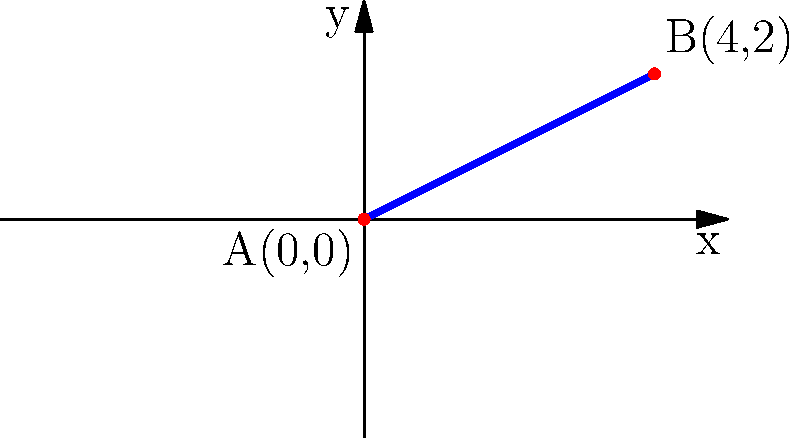During a breakaway, a player skates from point A(0,0) to point B(4,2) on the ice rink. Determine the slope of the line representing the player's path. How does this relate to the player's angle of approach towards the goal? To find the slope of the line representing the player's path, we'll follow these steps:

1) The slope formula is:
   $$ m = \frac{y_2 - y_1}{x_2 - x_1} $$
   where $(x_1, y_1)$ is the starting point and $(x_2, y_2)$ is the ending point.

2) We have:
   Point A: $(x_1, y_1) = (0, 0)$
   Point B: $(x_2, y_2) = (4, 2)$

3) Plugging these into the formula:
   $$ m = \frac{2 - 0}{4 - 0} = \frac{2}{4} = \frac{1}{2} $$

4) The slope is $\frac{1}{2}$ or 0.5.

5) In hockey terms, this slope indicates that for every 4 units the player moves horizontally, they move 2 units vertically. This represents a relatively direct path to the goal.

6) The slope relates to the angle of approach as follows:
   $$ \tan(\theta) = \text{slope} = \frac{1}{2} $$
   where $\theta$ is the angle between the player's path and the horizontal.

7) We can find this angle:
   $$ \theta = \arctan(\frac{1}{2}) \approx 26.57° $$

This angle of about 26.57° represents a fairly direct approach to the goal, allowing the player to maintain speed while still having a good shooting angle.
Answer: $\frac{1}{2}$ or 0.5 